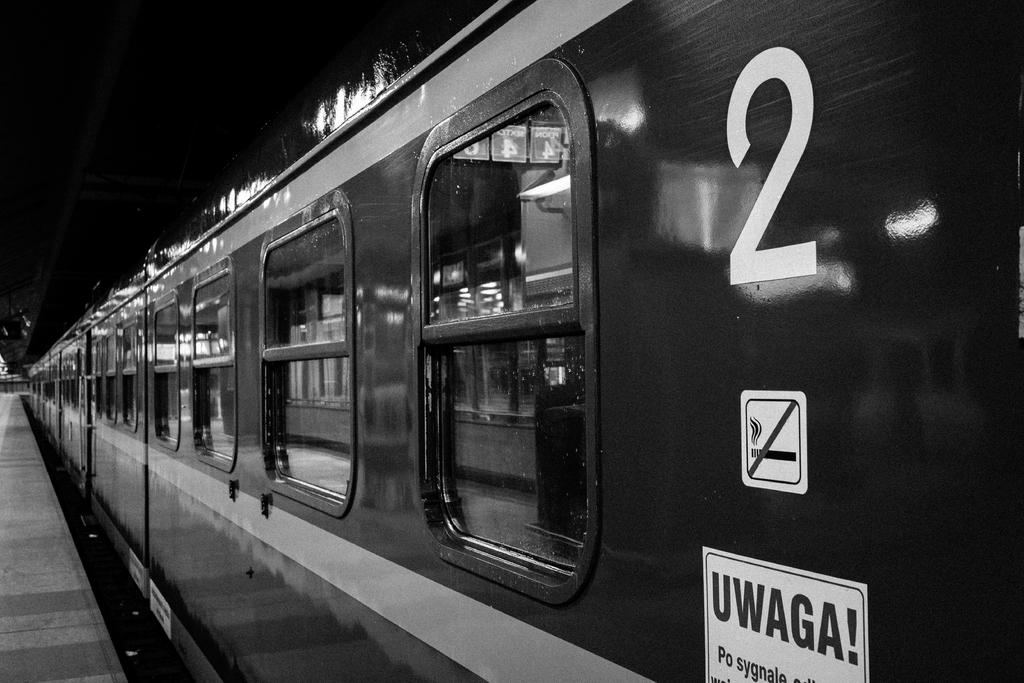What train number is this?
Keep it short and to the point. 2. What does the bold letters say to the right?
Keep it short and to the point. Uwaga. 